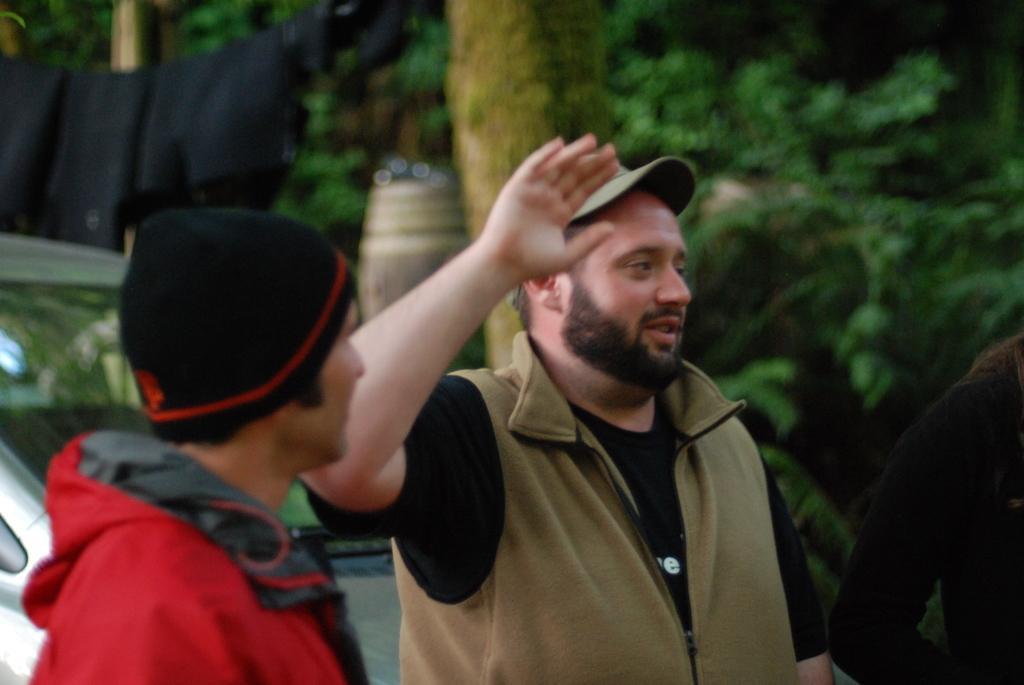How would you summarize this image in a sentence or two? In front of the picture, we see two men are standing. The man in the middle of the picture is raising his hand and I think he is trying to talk something. Behind them, we see a car. There are trees in the background. This picture is blurred in the background. 